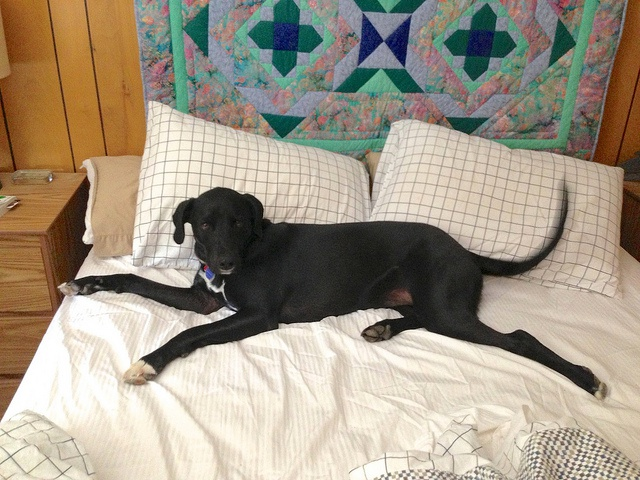Describe the objects in this image and their specific colors. I can see bed in brown, ivory, lightgray, tan, and darkgray tones and dog in brown, black, gray, and darkgray tones in this image. 